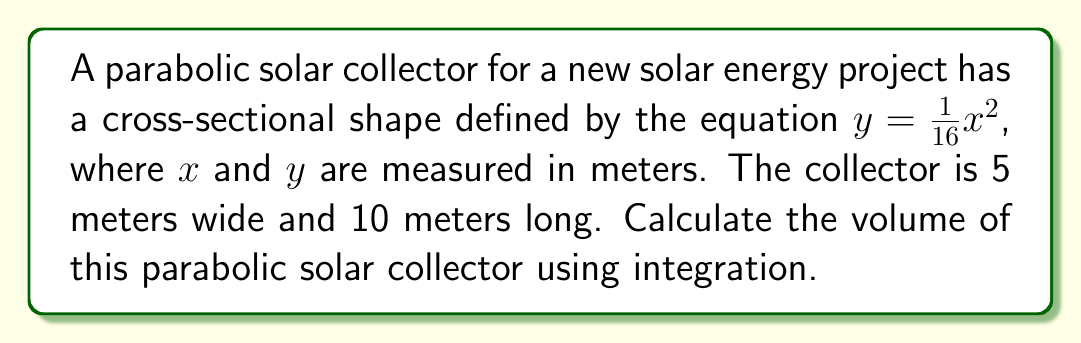Help me with this question. To find the volume of the parabolic solar collector, we need to use the method of integration. Here's a step-by-step approach:

1) The cross-section of the collector is a parabola defined by $y = \frac{1}{16}x^2$.

2) The width of the collector is 5 meters, so $x$ ranges from -2.5 to 2.5 meters.

3) We can find the volume by integrating the area of each cross-section along the length of the collector. This is a perfect application for the washer method.

4) The area of each cross-section is given by:

   $$A(x) = 2\int_0^{\frac{1}{16}x^2} dy = 2y = 2 \cdot \frac{1}{16}x^2 = \frac{1}{8}x^2$$

5) Now, we integrate this area over the width of the collector:

   $$V = \int_{-2.5}^{2.5} \frac{1}{8}x^2 dx$$

6) Evaluating this integral:

   $$V = \frac{1}{8} \cdot \frac{1}{3}x^3 \bigg|_{-2.5}^{2.5}$$
   
   $$V = \frac{1}{24} \left[(2.5)^3 - (-2.5)^3\right]$$
   
   $$V = \frac{1}{24} \left[15.625 + 15.625\right] = \frac{31.25}{24} \approx 1.302$$

7) This gives us the volume of a 1-meter long section. To get the total volume, we multiply by the length (10 meters):

   $$V_{total} = 10 \cdot \frac{31.25}{24} = \frac{3125}{24} \approx 13.02$$

Therefore, the volume of the parabolic solar collector is approximately 13.02 cubic meters.
Answer: $\frac{3125}{24}$ m³ or approximately 13.02 m³ 